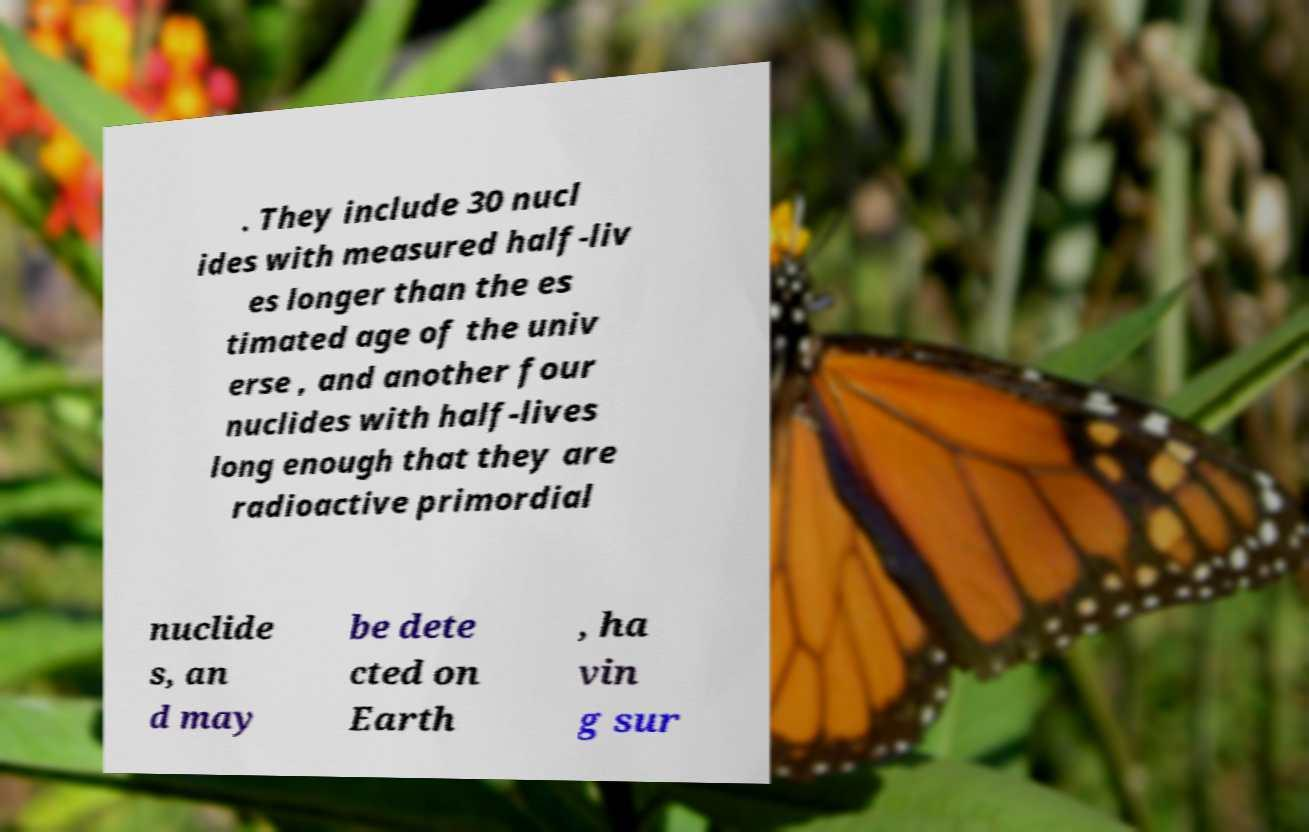Can you read and provide the text displayed in the image?This photo seems to have some interesting text. Can you extract and type it out for me? . They include 30 nucl ides with measured half-liv es longer than the es timated age of the univ erse , and another four nuclides with half-lives long enough that they are radioactive primordial nuclide s, an d may be dete cted on Earth , ha vin g sur 